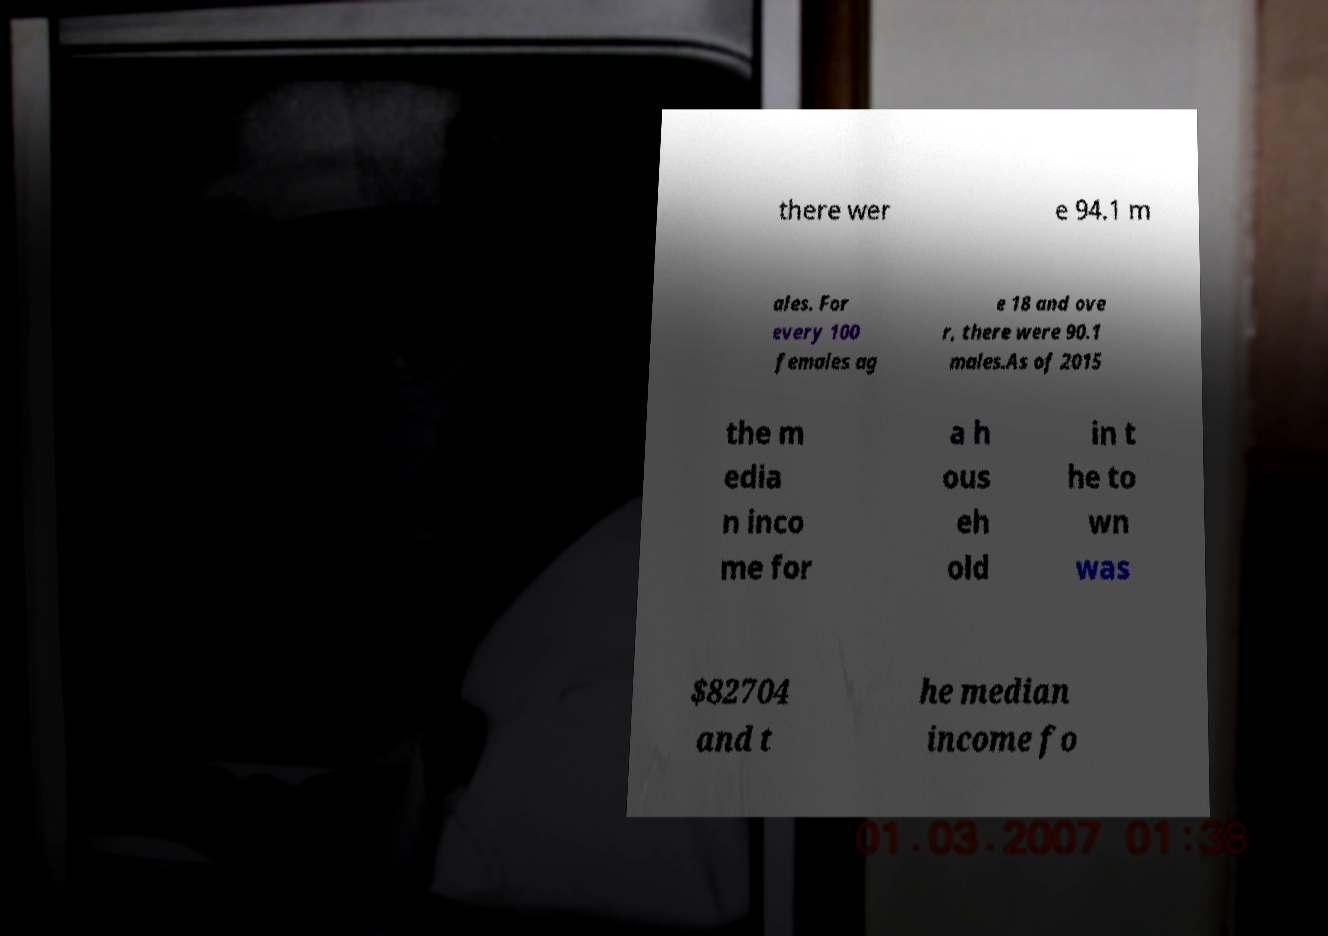What messages or text are displayed in this image? I need them in a readable, typed format. there wer e 94.1 m ales. For every 100 females ag e 18 and ove r, there were 90.1 males.As of 2015 the m edia n inco me for a h ous eh old in t he to wn was $82704 and t he median income fo 